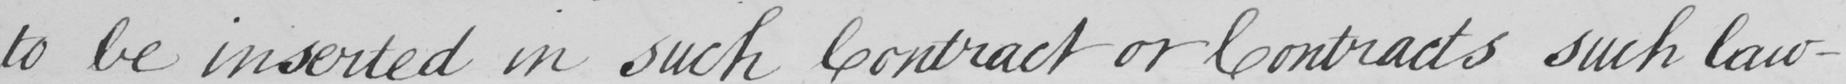Transcribe the text shown in this historical manuscript line. to be inserted in such Contract or Contracts such law- 